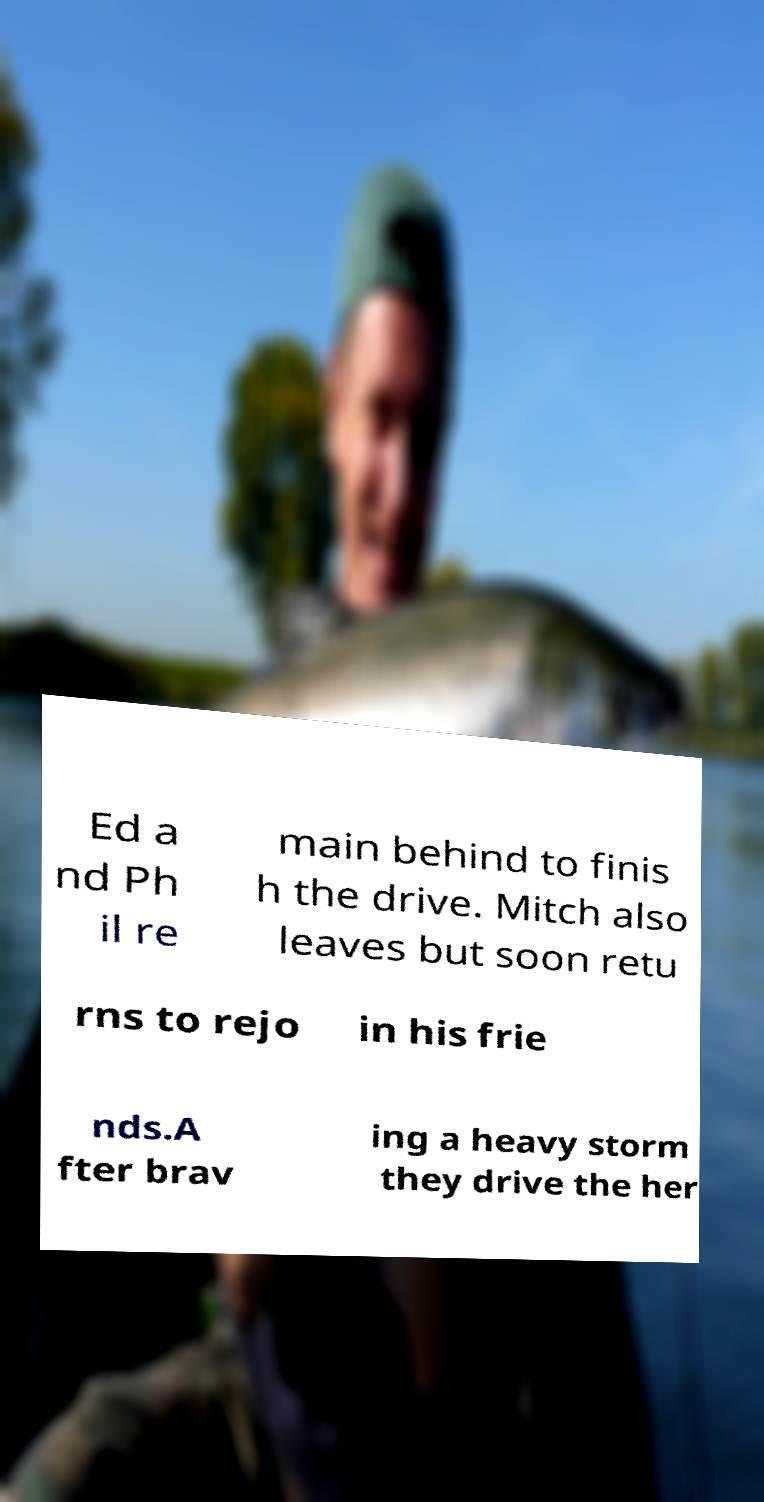Please identify and transcribe the text found in this image. Ed a nd Ph il re main behind to finis h the drive. Mitch also leaves but soon retu rns to rejo in his frie nds.A fter brav ing a heavy storm they drive the her 